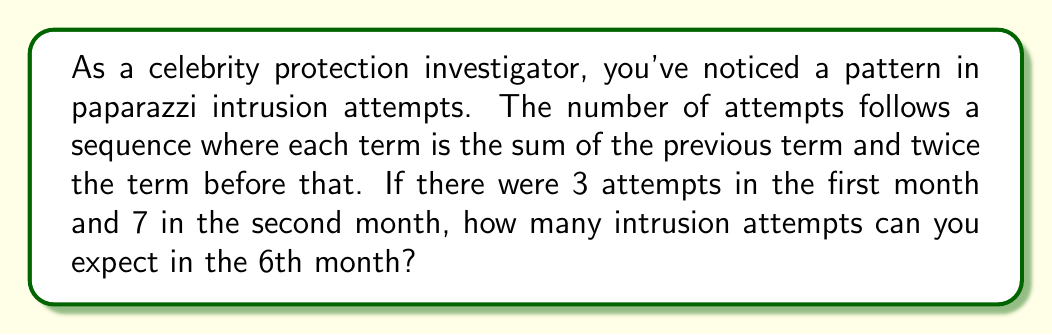Help me with this question. Let's approach this step-by-step:

1) First, let's define our sequence. Let $a_n$ be the number of intrusion attempts in the nth month.

2) Given information:
   $a_1 = 3$
   $a_2 = 7$

3) The rule for the sequence is:
   $a_n = a_{n-1} + 2a_{n-2}$ for $n \geq 3$

4) Let's calculate the next few terms:
   $a_3 = a_2 + 2a_1 = 7 + 2(3) = 13$
   $a_4 = a_3 + 2a_2 = 13 + 2(7) = 27$
   $a_5 = a_4 + 2a_3 = 27 + 2(13) = 53$
   $a_6 = a_5 + 2a_4 = 53 + 2(27) = 107$

5) Therefore, in the 6th month, we can expect 107 intrusion attempts.

This sequence grows rapidly due to the multiplication by 2 in each step, making it more aggressive than a standard Fibonacci sequence.
Answer: 107 